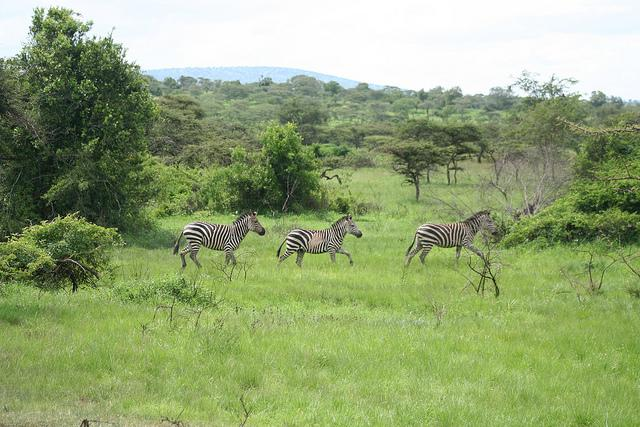What place are the zebra in? forrest 